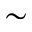Convert formula to latex. <formula><loc_0><loc_0><loc_500><loc_500>\sim</formula> 